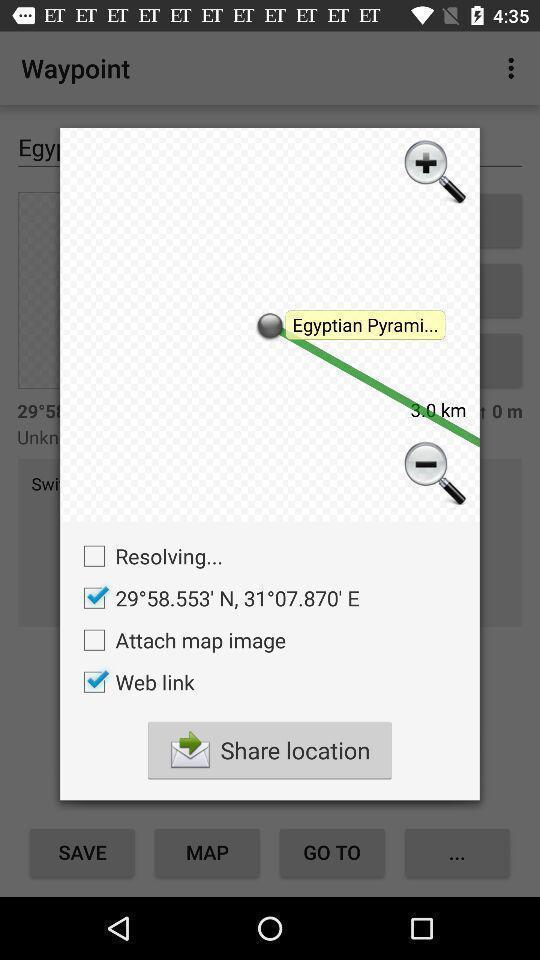Explain what's happening in this screen capture. Popup showing to share the location. 